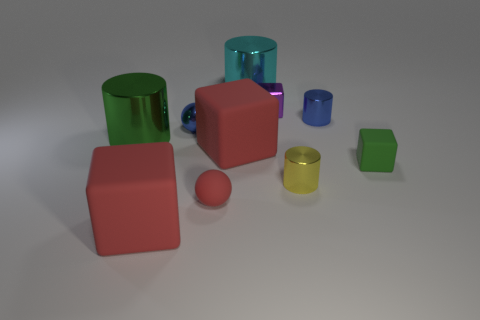Subtract all cubes. How many objects are left? 6 Subtract all blue metal spheres. Subtract all tiny yellow cylinders. How many objects are left? 8 Add 4 small blue cylinders. How many small blue cylinders are left? 5 Add 6 yellow shiny objects. How many yellow shiny objects exist? 7 Subtract 0 yellow spheres. How many objects are left? 10 